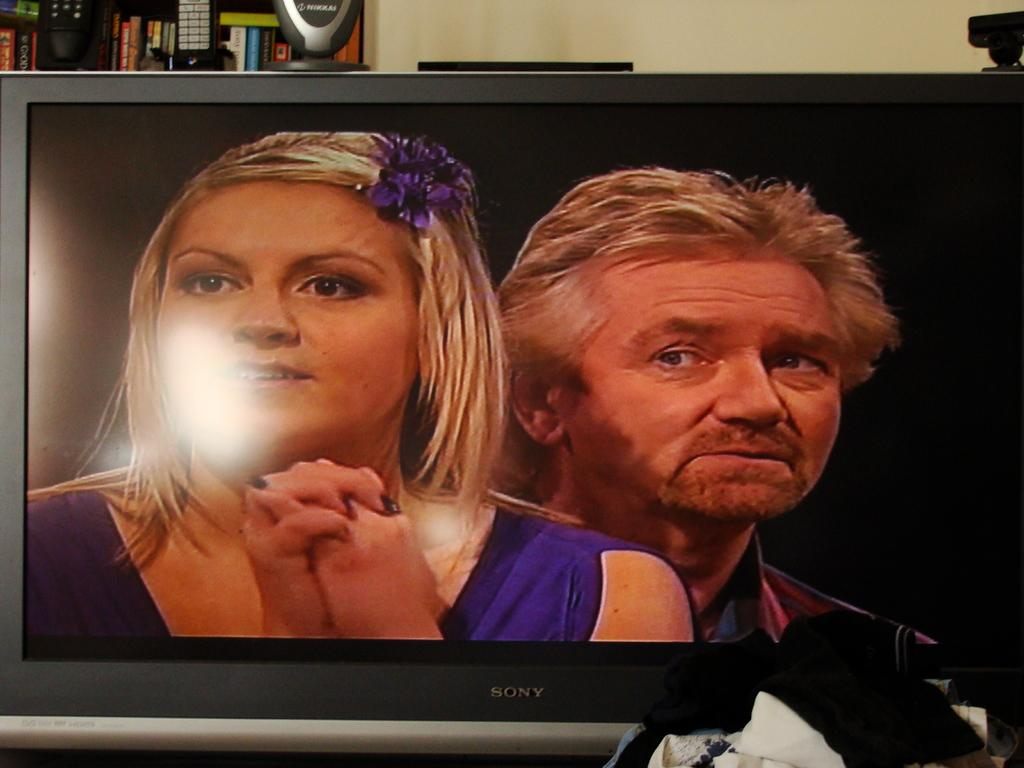What is the main object in the image? There is a screen in the image. What can be seen on the screen? People are visible on the screen. What type of objects are present in the background of the image? There are books, a wall, and other objects in the background of the image. Can you see any guns in the image? No, there are no guns present in the image. What type of soda is being served in the image? There is no soda visible in the image. 